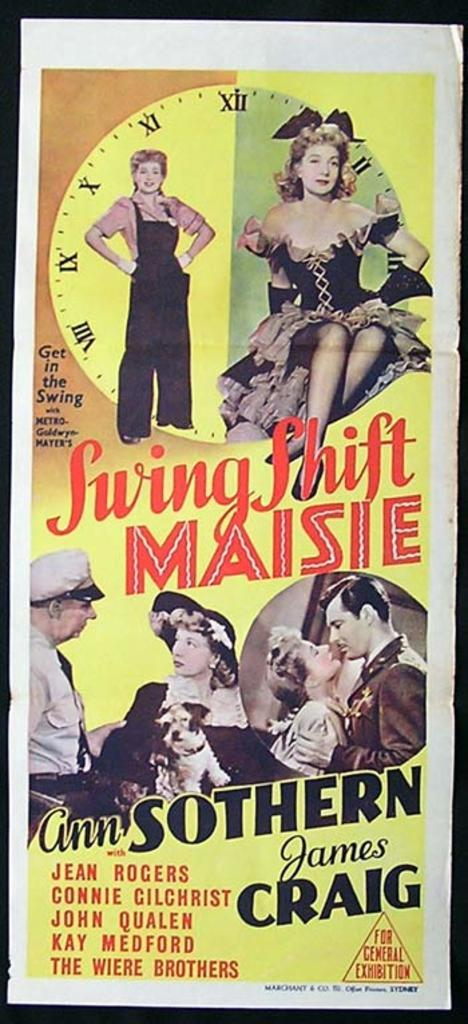<image>
Summarize the visual content of the image. A 1943 poster from the film Swing Shift Maisie is displayed with bold red and black lettering. 